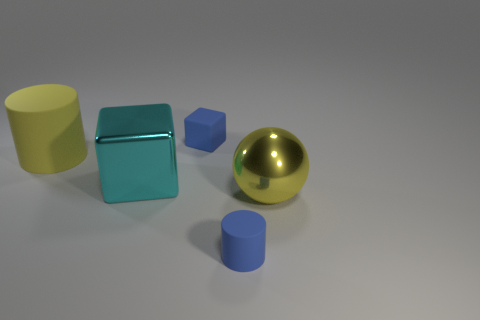Is there a object to the right of the big metal thing on the left side of the yellow ball?
Your answer should be compact. Yes. How many objects are big brown balls or balls?
Provide a short and direct response. 1. There is a tiny object right of the small thing left of the blue object that is in front of the small blue matte block; what color is it?
Ensure brevity in your answer.  Blue. Is there anything else of the same color as the tiny cylinder?
Offer a very short reply. Yes. Is the metal sphere the same size as the blue rubber block?
Offer a terse response. No. What number of things are rubber objects that are in front of the large yellow metal object or blue rubber things right of the blue rubber block?
Provide a short and direct response. 1. The blue object that is left of the rubber thing in front of the big shiny cube is made of what material?
Ensure brevity in your answer.  Rubber. How many other objects are there of the same material as the small cylinder?
Offer a terse response. 2. There is a blue thing in front of the large yellow metal sphere; how big is it?
Offer a very short reply. Small. There is a ball; is its size the same as the blue object behind the yellow rubber cylinder?
Give a very brief answer. No. 